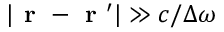Convert formula to latex. <formula><loc_0><loc_0><loc_500><loc_500>| r - r ^ { \prime } | \gg c / \Delta \omega</formula> 